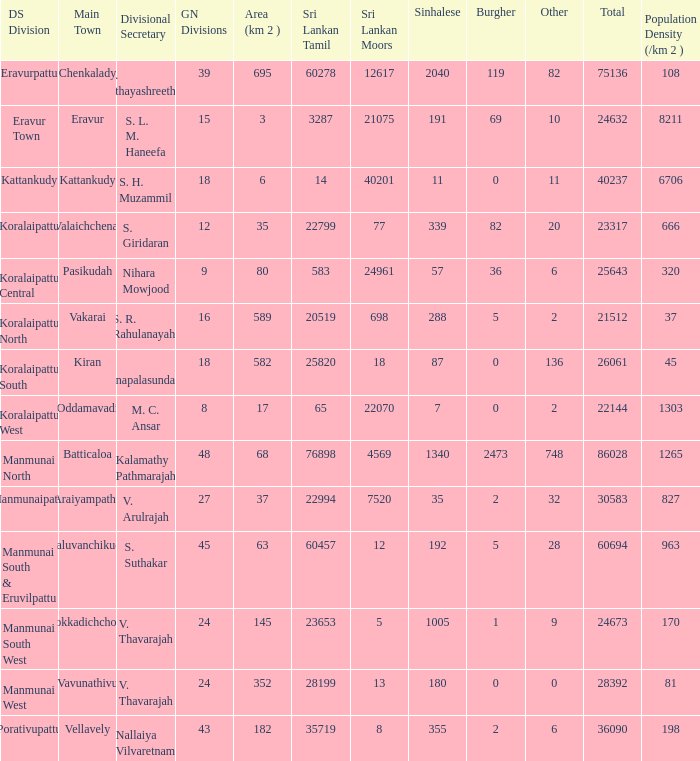Parse the full table. {'header': ['DS Division', 'Main Town', 'Divisional Secretary', 'GN Divisions', 'Area (km 2 )', 'Sri Lankan Tamil', 'Sri Lankan Moors', 'Sinhalese', 'Burgher', 'Other', 'Total', 'Population Density (/km 2 )'], 'rows': [['Eravurpattu', 'Chenkalady', 'U. Uthayashreethar', '39', '695', '60278', '12617', '2040', '119', '82', '75136', '108'], ['Eravur Town', 'Eravur', 'S. L. M. Haneefa', '15', '3', '3287', '21075', '191', '69', '10', '24632', '8211'], ['Kattankudy', 'Kattankudy', 'S. H. Muzammil', '18', '6', '14', '40201', '11', '0', '11', '40237', '6706'], ['Koralaipattu', 'Valaichchenai', 'S. Giridaran', '12', '35', '22799', '77', '339', '82', '20', '23317', '666'], ['Koralaipattu Central', 'Pasikudah', 'Nihara Mowjood', '9', '80', '583', '24961', '57', '36', '6', '25643', '320'], ['Koralaipattu North', 'Vakarai', 'S. R. Rahulanayahi', '16', '589', '20519', '698', '288', '5', '2', '21512', '37'], ['Koralaipattu South', 'Kiran', 'K. Thanapalasundaram', '18', '582', '25820', '18', '87', '0', '136', '26061', '45'], ['Koralaipattu West', 'Oddamavadi', 'M. C. Ansar', '8', '17', '65', '22070', '7', '0', '2', '22144', '1303'], ['Manmunai North', 'Batticaloa', 'Kalamathy Pathmarajah', '48', '68', '76898', '4569', '1340', '2473', '748', '86028', '1265'], ['Manmunaipattu', 'Araiyampathy', 'V. Arulrajah', '27', '37', '22994', '7520', '35', '2', '32', '30583', '827'], ['Manmunai South & Eruvilpattu', 'Kaluvanchikudy', 'S. Suthakar', '45', '63', '60457', '12', '192', '5', '28', '60694', '963'], ['Manmunai South West', 'Kokkadichcholai', 'V. Thavarajah', '24', '145', '23653', '5', '1005', '1', '9', '24673', '170'], ['Manmunai West', 'Vavunathivu', 'V. Thavarajah', '24', '352', '28199', '13', '180', '0', '0', '28392', '81'], ['Porativupattu', 'Vellavely', 'Nallaiya Vilvaretnam', '43', '182', '35719', '8', '355', '2', '6', '36090', '198']]} What DS division has S. L. M. Haneefa as the divisional secretary? Eravur Town. 